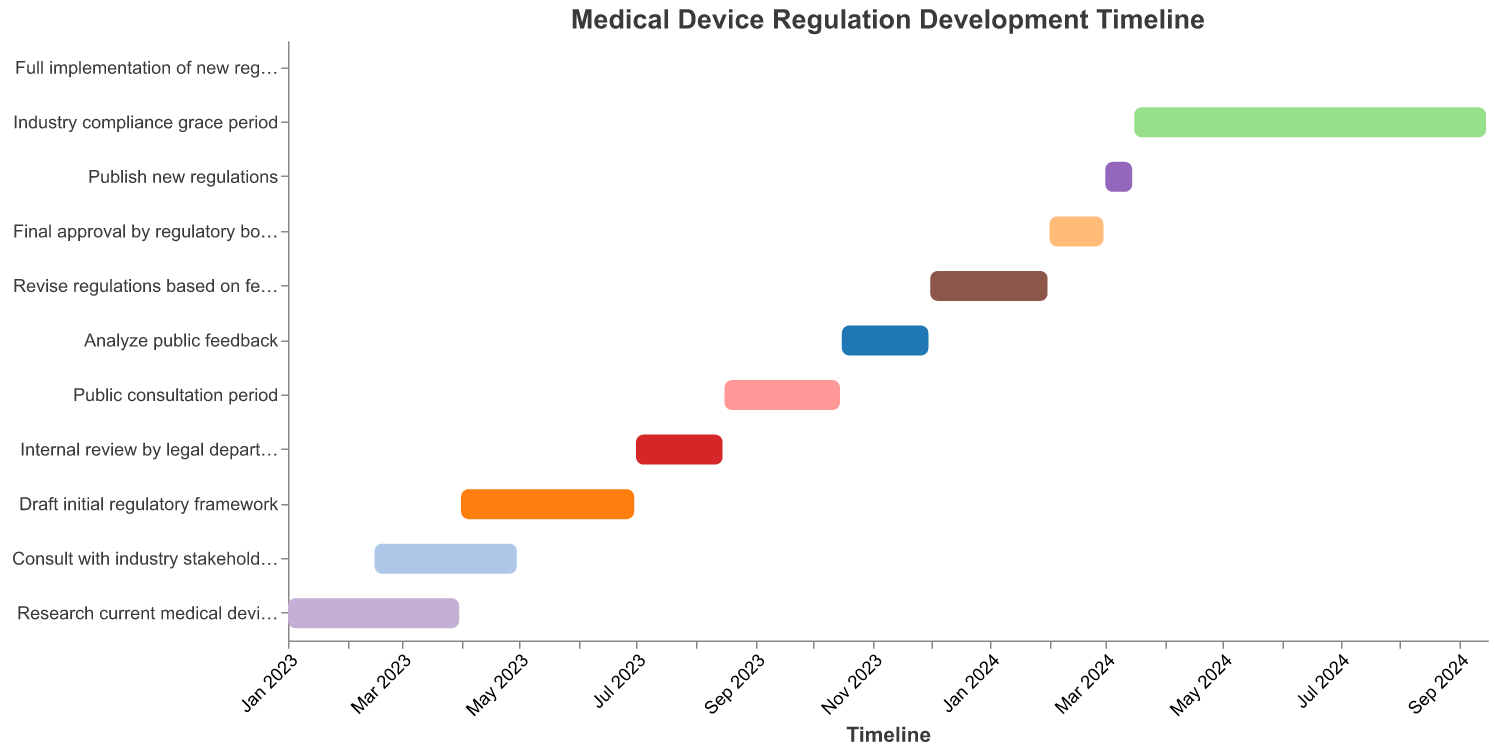What's the title of the chart? The title is usually positioned at the top of the chart and provides a summary of what the chart represents. In this case, it reads "Medical Device Regulation Development Timeline".
Answer: Medical Device Regulation Development Timeline How long is the "Public consultation period"? The Gantt chart bars represent the duration of each task. The "Public consultation period" starts on August 16, 2023, and ends on October 15, 2023. Subtracting the start date from the end date gives the duration.
Answer: 61 days Which task ends in October 2023? By examining the end dates of each task, we see that the "Public consultation period" ends on October 15, 2023.
Answer: Public consultation period How many tasks are there in total? Each bar in the Gantt chart represents a task. Counting the bars gives the total number of tasks.
Answer: 11 tasks Which task has the shortest duration? The task with the shortest bar represents the shortest duration. In this Gantt chart, "Full implementation of new regulations" occurs on a single day, September 16, 2024.
Answer: Full implementation of new regulations What tasks are running concurrently with the "Public consultation period"? Tasks running concurrently will have overlapping bars. "Analyze public feedback" starts on October 16, 2023, slightly after the "Public consultation period," but "Internal review by legal department" ends on August 15, 2023, and thus is not concurrent. Hence, no tasks fully overlap with "Public consultation period".
Answer: None How does the duration of "Industry compliance grace period" compare to "Draft initial regulatory framework"? The "Industry compliance grace period" runs from March 16, 2024, to September 15, 2024, which is six months. The "Draft initial regulatory framework" runs from April 1, 2023, to June 30, 2023, which is three months.
Answer: Twice as long Which stage involves public interaction and feedback? By analyzing the names of the tasks, "Public consultation period" and "Analyze public feedback" suggest public interaction.
Answer: Public consultation period and Analyze public feedback When does the final approval of the regulations take place? The bar for "Final approval by regulatory board" indicates the duration. It starts on February 1, 2024, and ends on February 29, 2024.
Answer: February 2024 